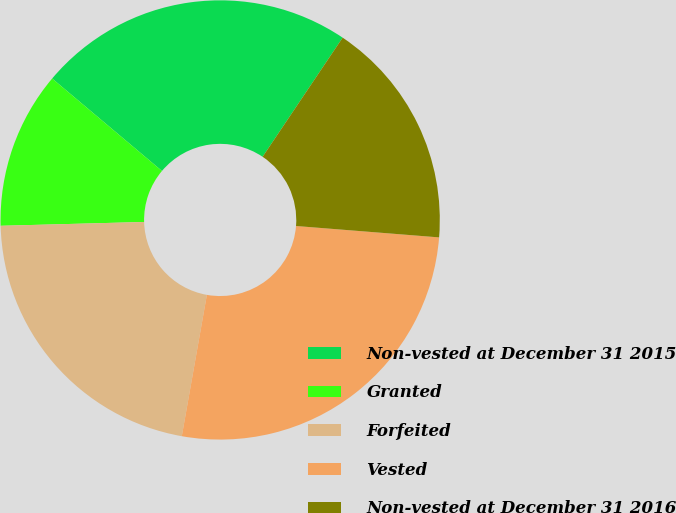<chart> <loc_0><loc_0><loc_500><loc_500><pie_chart><fcel>Non-vested at December 31 2015<fcel>Granted<fcel>Forfeited<fcel>Vested<fcel>Non-vested at December 31 2016<nl><fcel>23.28%<fcel>11.56%<fcel>21.78%<fcel>26.53%<fcel>16.85%<nl></chart> 